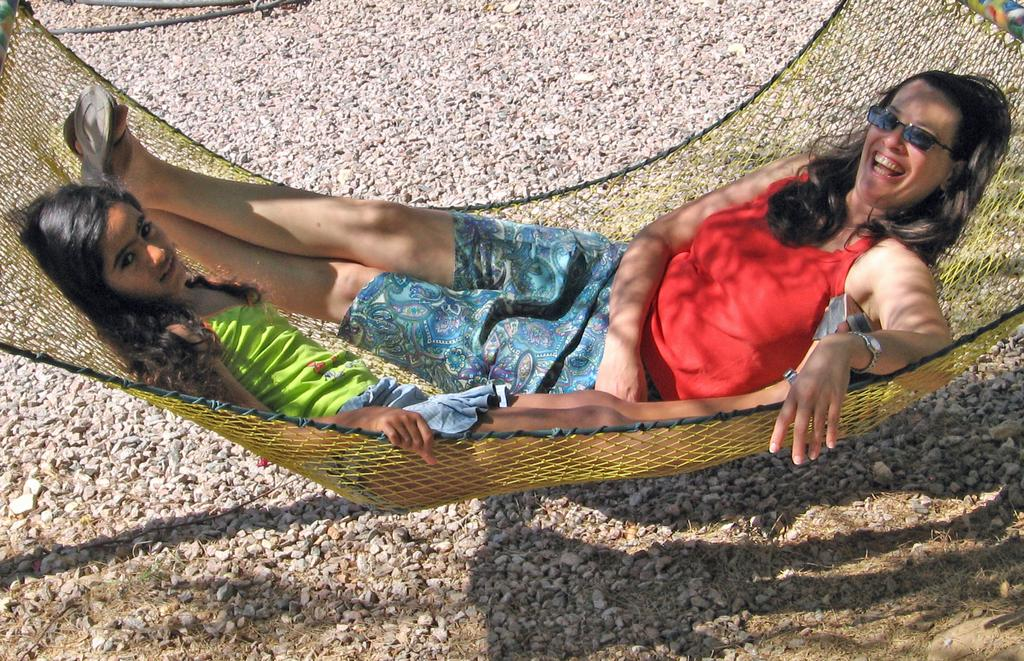How many people are in the image? There are two persons in the image. What are the persons doing in the image? The persons are lying on a hammock and posing for a photo. What can be seen on the ground in the image? There are stones on the ground in the image. What type of memory is being used to store the photo in the image? There is no information about the type of memory being used to store the photo in the image. Can you hear any bells ringing in the image? There are no bells or any indication of sound in the image. 